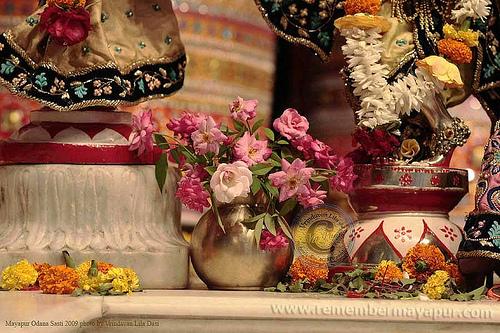Is the vase with the pink flowers shiny?
Concise answer only. Yes. What is pink in the photo?
Keep it brief. Flowers. Is there a website on the picture?
Answer briefly. Yes. 